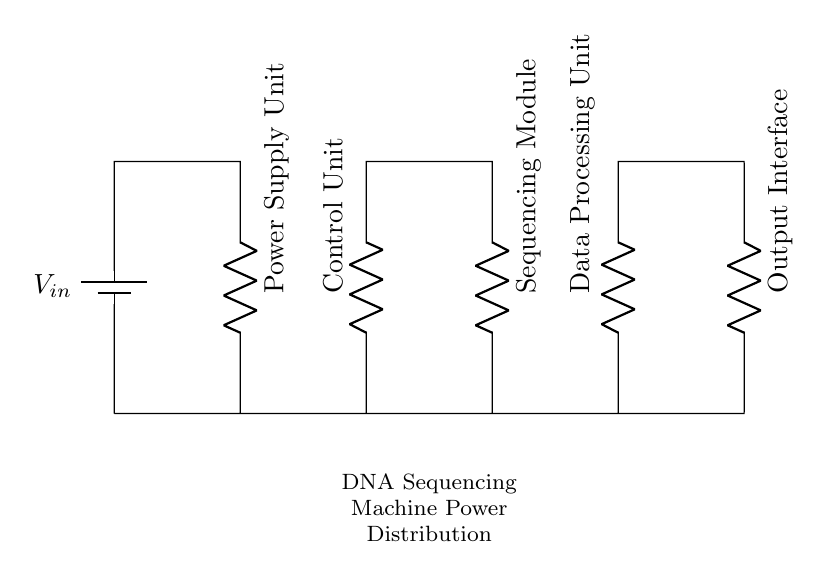What type of circuit is depicted? The circuit is a series circuit since all components are connected in a single path for current flow.
Answer: series circuit How many resistors are present? By analyzing the diagram, four distinct resistors can be identified, each representing a different component in the power distribution.
Answer: four What is the function of the Control Unit? The Control Unit regulates the operation of different modules in the DNA sequencing machine, ensuring proper functioning and power distribution.
Answer: regulates operation Which component is the first in the power distribution path? The initial component encountered in the path is the battery, providing the input voltage necessary for the circuit to operate.
Answer: battery What is the final component in the circuit? The last component in the series circuit, after all resistors, is the Output Interface, responsible for outputting the processed data.
Answer: Output Interface How does the arrangement of components affect the circuit? The series arrangement means that the same current flows through all components, leading to the same current being used, affecting voltage distribution among them.
Answer: same current 